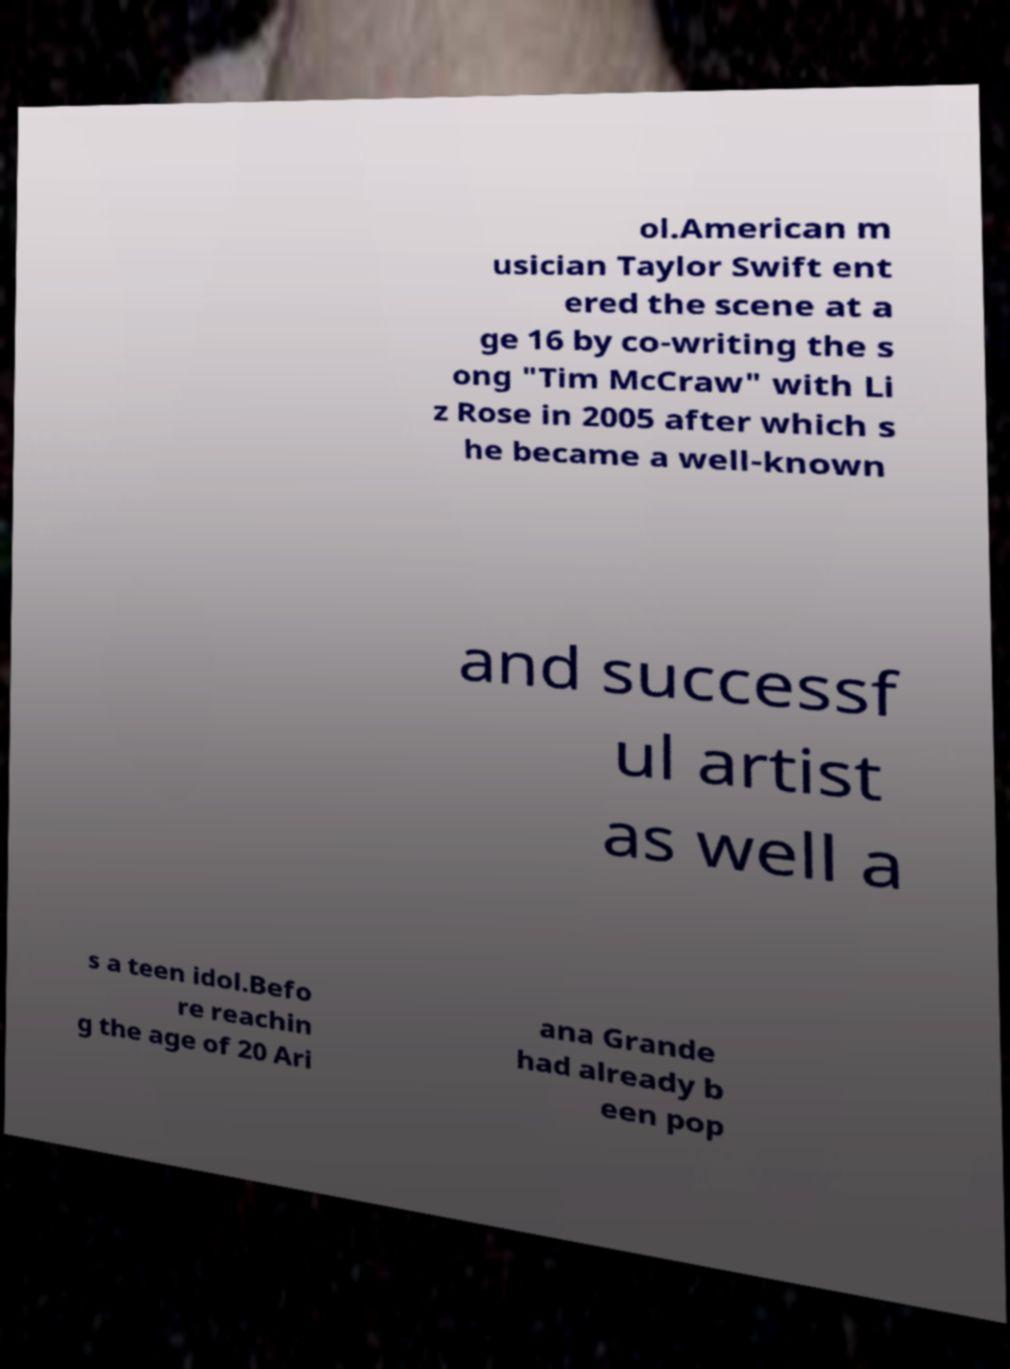Could you assist in decoding the text presented in this image and type it out clearly? ol.American m usician Taylor Swift ent ered the scene at a ge 16 by co-writing the s ong "Tim McCraw" with Li z Rose in 2005 after which s he became a well-known and successf ul artist as well a s a teen idol.Befo re reachin g the age of 20 Ari ana Grande had already b een pop 